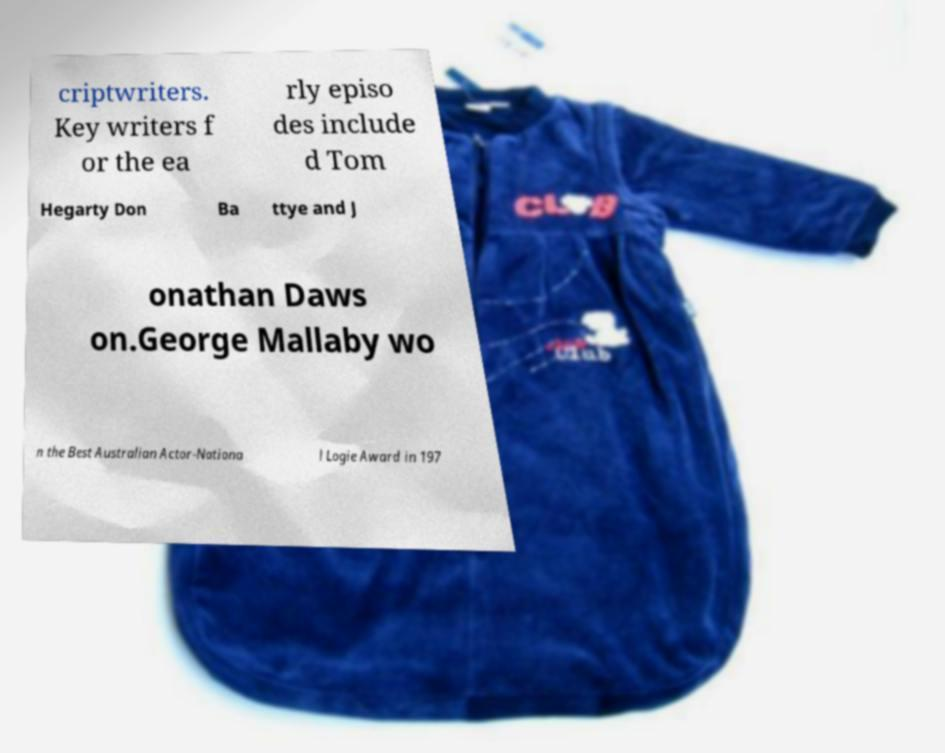Can you accurately transcribe the text from the provided image for me? criptwriters. Key writers f or the ea rly episo des include d Tom Hegarty Don Ba ttye and J onathan Daws on.George Mallaby wo n the Best Australian Actor-Nationa l Logie Award in 197 